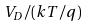Convert formula to latex. <formula><loc_0><loc_0><loc_500><loc_500>V _ { D } / ( k T / q )</formula> 